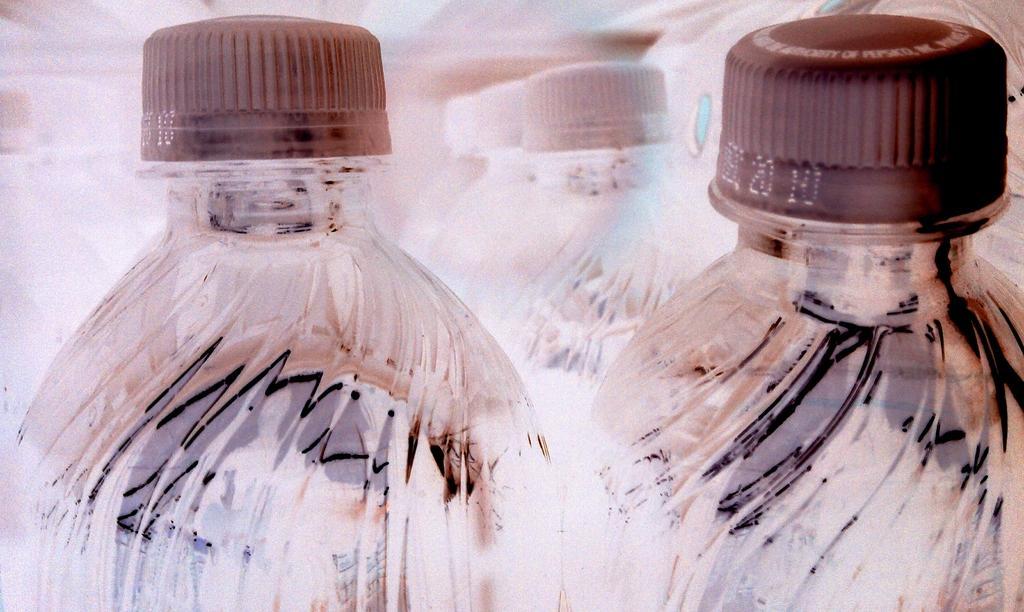In one or two sentences, can you explain what this image depicts? There are many bottles. In front these two are with brown color caps and in the background, remaining are with white color caps. 